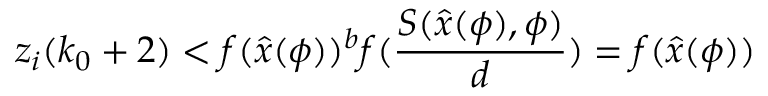<formula> <loc_0><loc_0><loc_500><loc_500>z _ { i } ( k _ { 0 } + 2 ) < f ( \hat { x } ( \phi ) ) ^ { b } f ( \frac { S ( \hat { x } ( \phi ) , \phi ) } { d } ) = f ( \hat { x } ( \phi ) )</formula> 